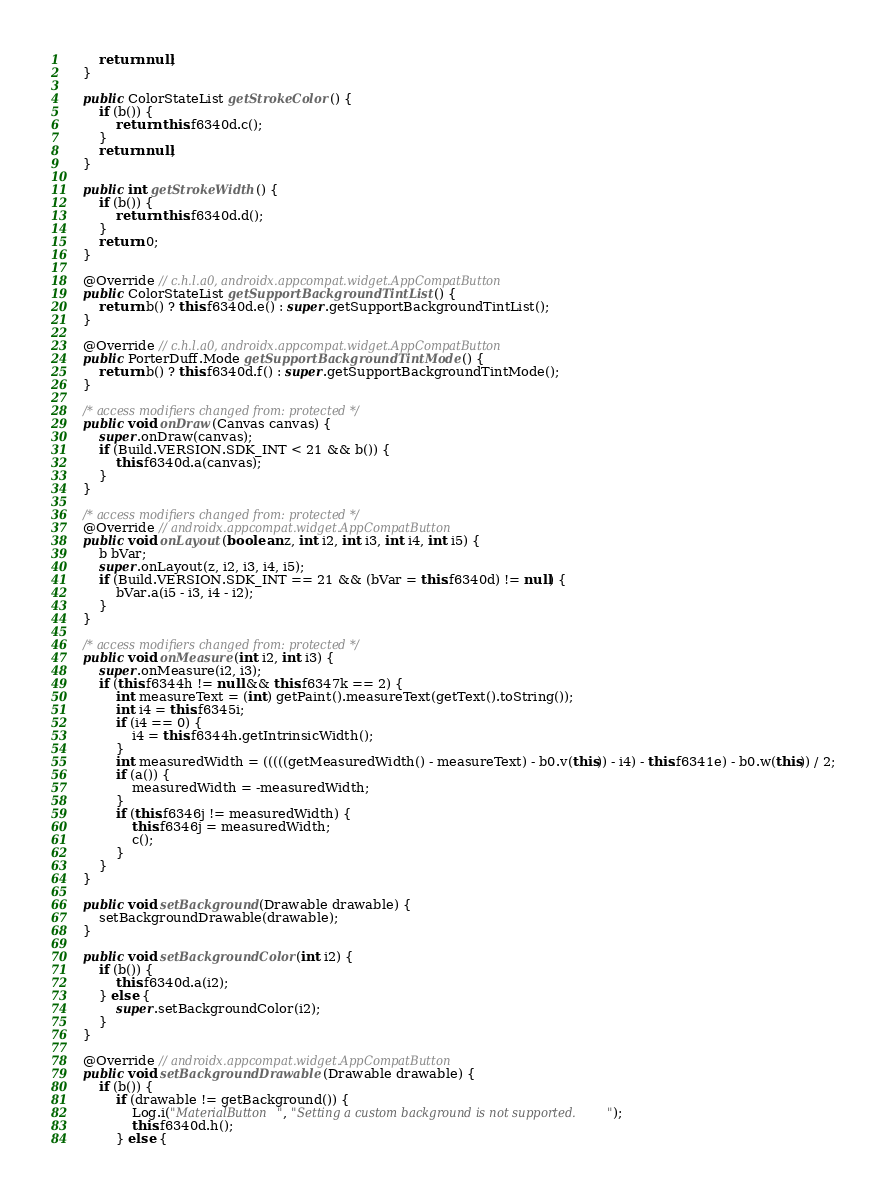Convert code to text. <code><loc_0><loc_0><loc_500><loc_500><_Java_>        return null;
    }

    public ColorStateList getStrokeColor() {
        if (b()) {
            return this.f6340d.c();
        }
        return null;
    }

    public int getStrokeWidth() {
        if (b()) {
            return this.f6340d.d();
        }
        return 0;
    }

    @Override // c.h.l.a0, androidx.appcompat.widget.AppCompatButton
    public ColorStateList getSupportBackgroundTintList() {
        return b() ? this.f6340d.e() : super.getSupportBackgroundTintList();
    }

    @Override // c.h.l.a0, androidx.appcompat.widget.AppCompatButton
    public PorterDuff.Mode getSupportBackgroundTintMode() {
        return b() ? this.f6340d.f() : super.getSupportBackgroundTintMode();
    }

    /* access modifiers changed from: protected */
    public void onDraw(Canvas canvas) {
        super.onDraw(canvas);
        if (Build.VERSION.SDK_INT < 21 && b()) {
            this.f6340d.a(canvas);
        }
    }

    /* access modifiers changed from: protected */
    @Override // androidx.appcompat.widget.AppCompatButton
    public void onLayout(boolean z, int i2, int i3, int i4, int i5) {
        b bVar;
        super.onLayout(z, i2, i3, i4, i5);
        if (Build.VERSION.SDK_INT == 21 && (bVar = this.f6340d) != null) {
            bVar.a(i5 - i3, i4 - i2);
        }
    }

    /* access modifiers changed from: protected */
    public void onMeasure(int i2, int i3) {
        super.onMeasure(i2, i3);
        if (this.f6344h != null && this.f6347k == 2) {
            int measureText = (int) getPaint().measureText(getText().toString());
            int i4 = this.f6345i;
            if (i4 == 0) {
                i4 = this.f6344h.getIntrinsicWidth();
            }
            int measuredWidth = (((((getMeasuredWidth() - measureText) - b0.v(this)) - i4) - this.f6341e) - b0.w(this)) / 2;
            if (a()) {
                measuredWidth = -measuredWidth;
            }
            if (this.f6346j != measuredWidth) {
                this.f6346j = measuredWidth;
                c();
            }
        }
    }

    public void setBackground(Drawable drawable) {
        setBackgroundDrawable(drawable);
    }

    public void setBackgroundColor(int i2) {
        if (b()) {
            this.f6340d.a(i2);
        } else {
            super.setBackgroundColor(i2);
        }
    }

    @Override // androidx.appcompat.widget.AppCompatButton
    public void setBackgroundDrawable(Drawable drawable) {
        if (b()) {
            if (drawable != getBackground()) {
                Log.i("MaterialButton", "Setting a custom background is not supported.");
                this.f6340d.h();
            } else {</code> 